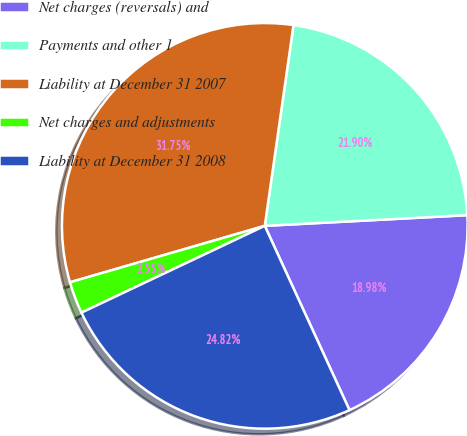Convert chart. <chart><loc_0><loc_0><loc_500><loc_500><pie_chart><fcel>Net charges (reversals) and<fcel>Payments and other 1<fcel>Liability at December 31 2007<fcel>Net charges and adjustments<fcel>Liability at December 31 2008<nl><fcel>18.98%<fcel>21.9%<fcel>31.75%<fcel>2.55%<fcel>24.82%<nl></chart> 